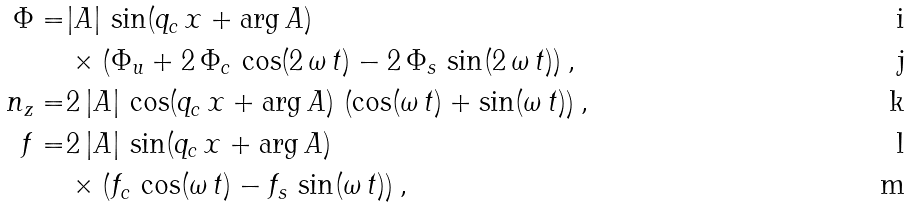<formula> <loc_0><loc_0><loc_500><loc_500>\Phi = & | A | \, \sin ( q _ { c } \, x + \arg A ) \, \\ & \times \left ( { { \Phi } _ { u } } + 2 \, { { \Phi } _ { c } } \, \cos ( 2 \, \omega \, t ) - 2 \, { { \Phi } _ { s } } \, \sin ( 2 \, \omega \, t ) \right ) , \\ n _ { z } = & 2 \, | A | \, \cos ( q _ { c } \, x + \arg A ) \, \left ( \cos ( \omega \, t ) + \sin ( \omega \, t ) \right ) , \\ f = & 2 \, | A | \, \sin ( q _ { c } \, x + \arg A ) \, \\ & \times \left ( { f _ { c } } \, \cos ( \omega \, t ) - { f _ { s } } \, \sin ( \omega \, t ) \right ) ,</formula> 